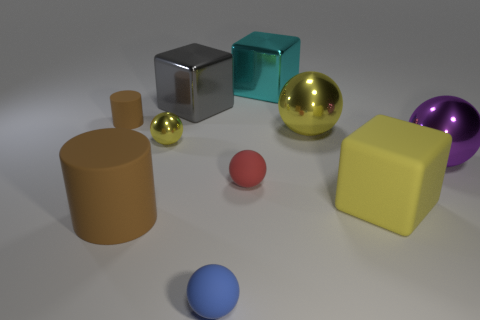How many tiny blue balls have the same material as the big yellow cube?
Provide a short and direct response. 1. Is there a gray shiny block?
Provide a short and direct response. Yes. How many metallic objects are the same color as the small metallic ball?
Provide a short and direct response. 1. Is the purple ball made of the same material as the block in front of the purple sphere?
Make the answer very short. No. Are there more brown cylinders behind the large yellow block than yellow matte spheres?
Provide a short and direct response. Yes. Is there any other thing that is the same size as the cyan metal cube?
Make the answer very short. Yes. There is a rubber cube; does it have the same color as the rubber cylinder that is in front of the purple thing?
Ensure brevity in your answer.  No. Are there the same number of things behind the tiny red matte sphere and yellow metallic spheres that are behind the big yellow shiny thing?
Give a very brief answer. No. What material is the cylinder that is in front of the purple shiny object?
Offer a terse response. Rubber. How many things are either brown matte things in front of the red matte object or small things?
Your answer should be compact. 5. 